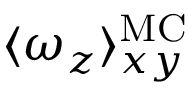<formula> <loc_0><loc_0><loc_500><loc_500>\langle \omega _ { z } \rangle _ { x y } ^ { M C }</formula> 